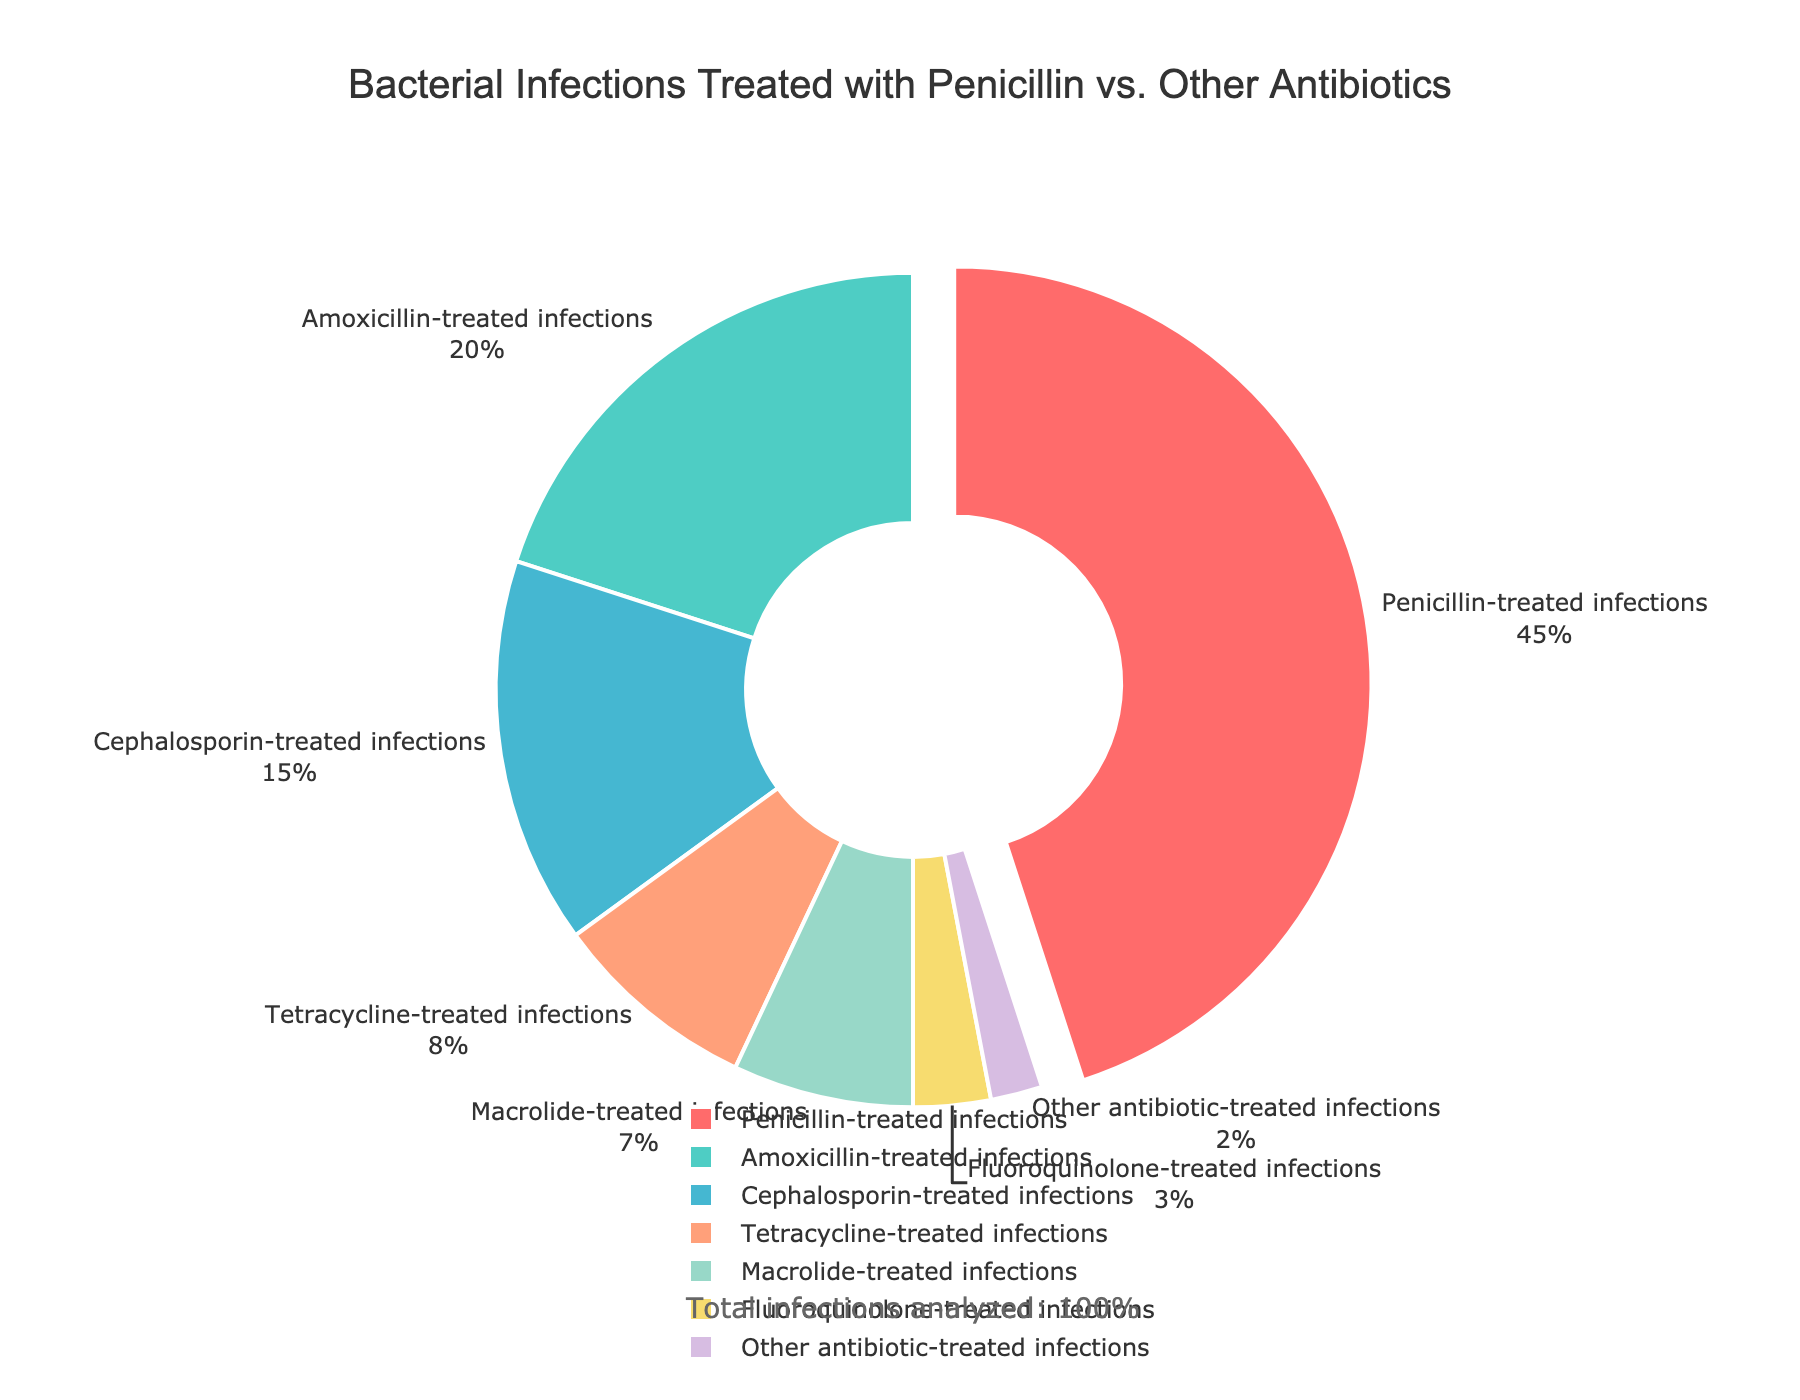What percentage of bacterial infections are treated with antibiotics other than penicillin? To find the percentage treated with antibiotics other than penicillin, sum the percentages of all other treatments: 20 (Amoxicillin) + 15 (Cephalosporin) + 8 (Tetracycline) + 7 (Macrolide) + 3 (Fluoroquinolone) + 2 (Other) = 55%.
Answer: 55% Which antibiotic treats the second-highest percentage of bacterial infections? From the pie chart, after penicillin (45%), the next highest percentage is treated with Amoxicillin (20%).
Answer: Amoxicillin What is the combined percentage of infections treated with Tetracycline and Macrolide? Add the percentages treated with Tetracycline and Macrolide: 8% (Tetracycline) + 7% (Macrolide) = 15%.
Answer: 15% How does the percentage of infections treated with Cephalosporin compare to the percentage treated with Fluoroquinolone? To compare percentages, observe that Cephalosporin treats 15% while Fluoroquinolone treats 3%. Cephalosporin treats a higher percentage.
Answer: Cephalosporin treats more What color represents infections treated with penicillin in the pie chart? In the pie chart, penicillin-treated infections (45%) are depicted in red.
Answer: Red Which infection type is depicted with the color green in the pie chart? By looking at the pie chart, Amoxicillin-treated infections (20%) are represented with the green section.
Answer: Amoxicillin What is the difference in percentage between the least and most common antibiotic treatments? The most common treatment is Penicillin (45%) and the least common is Other antibiotics (2%). The difference is 45% - 2% = 43%.
Answer: 43% Are there more infections treated with Penicillin or the combined total of infections treated with Tetracycline and Macrolide? Penicillin treats 45% of infections. Tetracycline and Macrolide together treat 8% + 7% = 15%. Penicillin treats more.
Answer: Penicillin treats more Which antibiotics collectively treat more than half of the infections? Summing the percentages for Penicillin (45%) and Amoxicillin (20%) results in 45% + 20% = 65%, which is more than half. So, Penicillin and Amoxicillin collectively treat more than half of the infections.
Answer: Penicillin and Amoxicillin If we combined the percentages of infections treated with Cephalosporin and Macrolide, would it be greater than the percentage treated with Amoxicillin? Cephalosporin treats 15% and Macrolide treats 7%, combined they treat 15% + 7% = 22%, which is greater than Amoxicillin's 20%.
Answer: Yes 